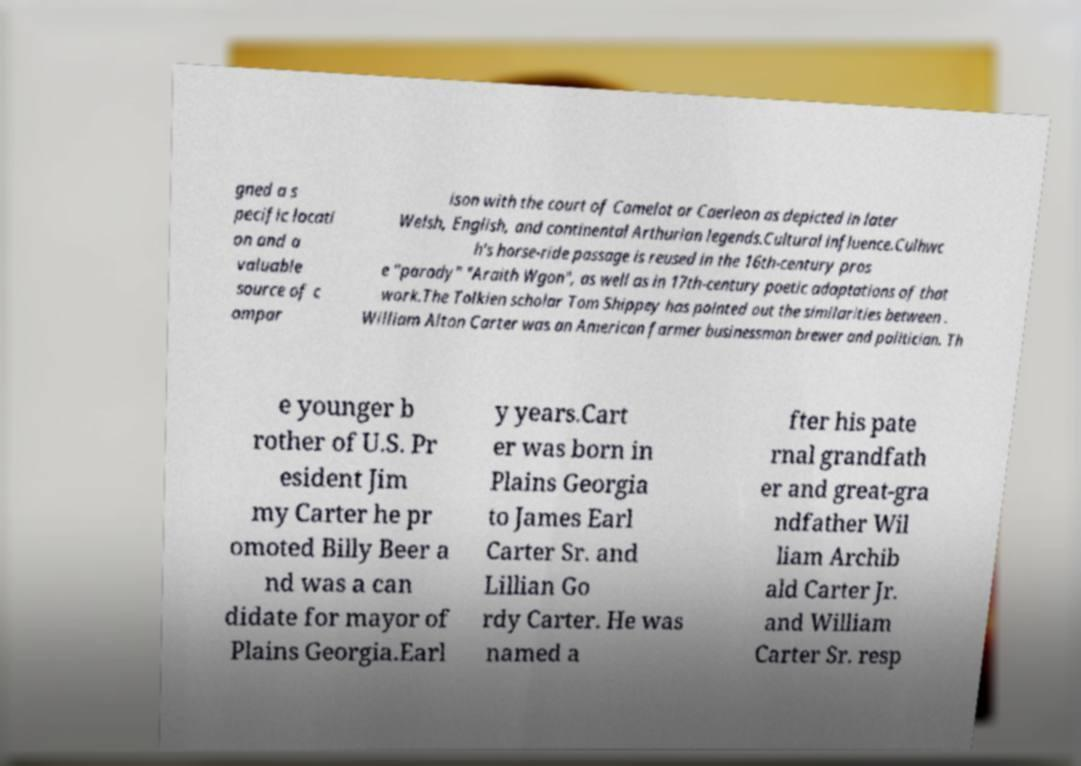Can you accurately transcribe the text from the provided image for me? gned a s pecific locati on and a valuable source of c ompar ison with the court of Camelot or Caerleon as depicted in later Welsh, English, and continental Arthurian legends.Cultural influence.Culhwc h's horse-ride passage is reused in the 16th-century pros e "parody" "Araith Wgon", as well as in 17th-century poetic adaptations of that work.The Tolkien scholar Tom Shippey has pointed out the similarities between . William Alton Carter was an American farmer businessman brewer and politician. Th e younger b rother of U.S. Pr esident Jim my Carter he pr omoted Billy Beer a nd was a can didate for mayor of Plains Georgia.Earl y years.Cart er was born in Plains Georgia to James Earl Carter Sr. and Lillian Go rdy Carter. He was named a fter his pate rnal grandfath er and great-gra ndfather Wil liam Archib ald Carter Jr. and William Carter Sr. resp 